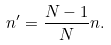Convert formula to latex. <formula><loc_0><loc_0><loc_500><loc_500>n ^ { \prime } = \frac { N - 1 } { N } n .</formula> 